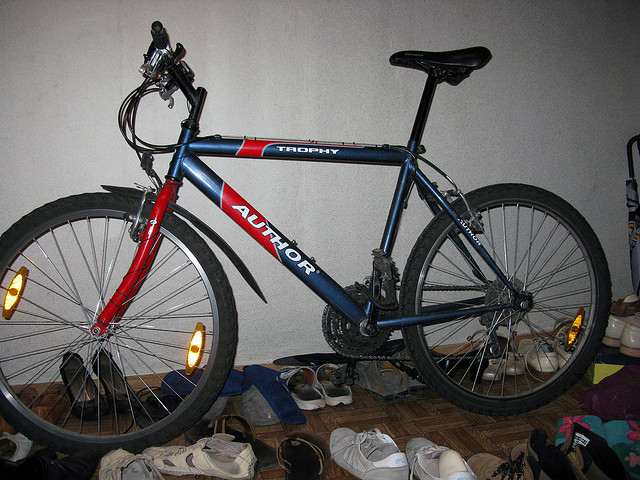Identify and read out the text in this image. AUTHOR TROPHY 